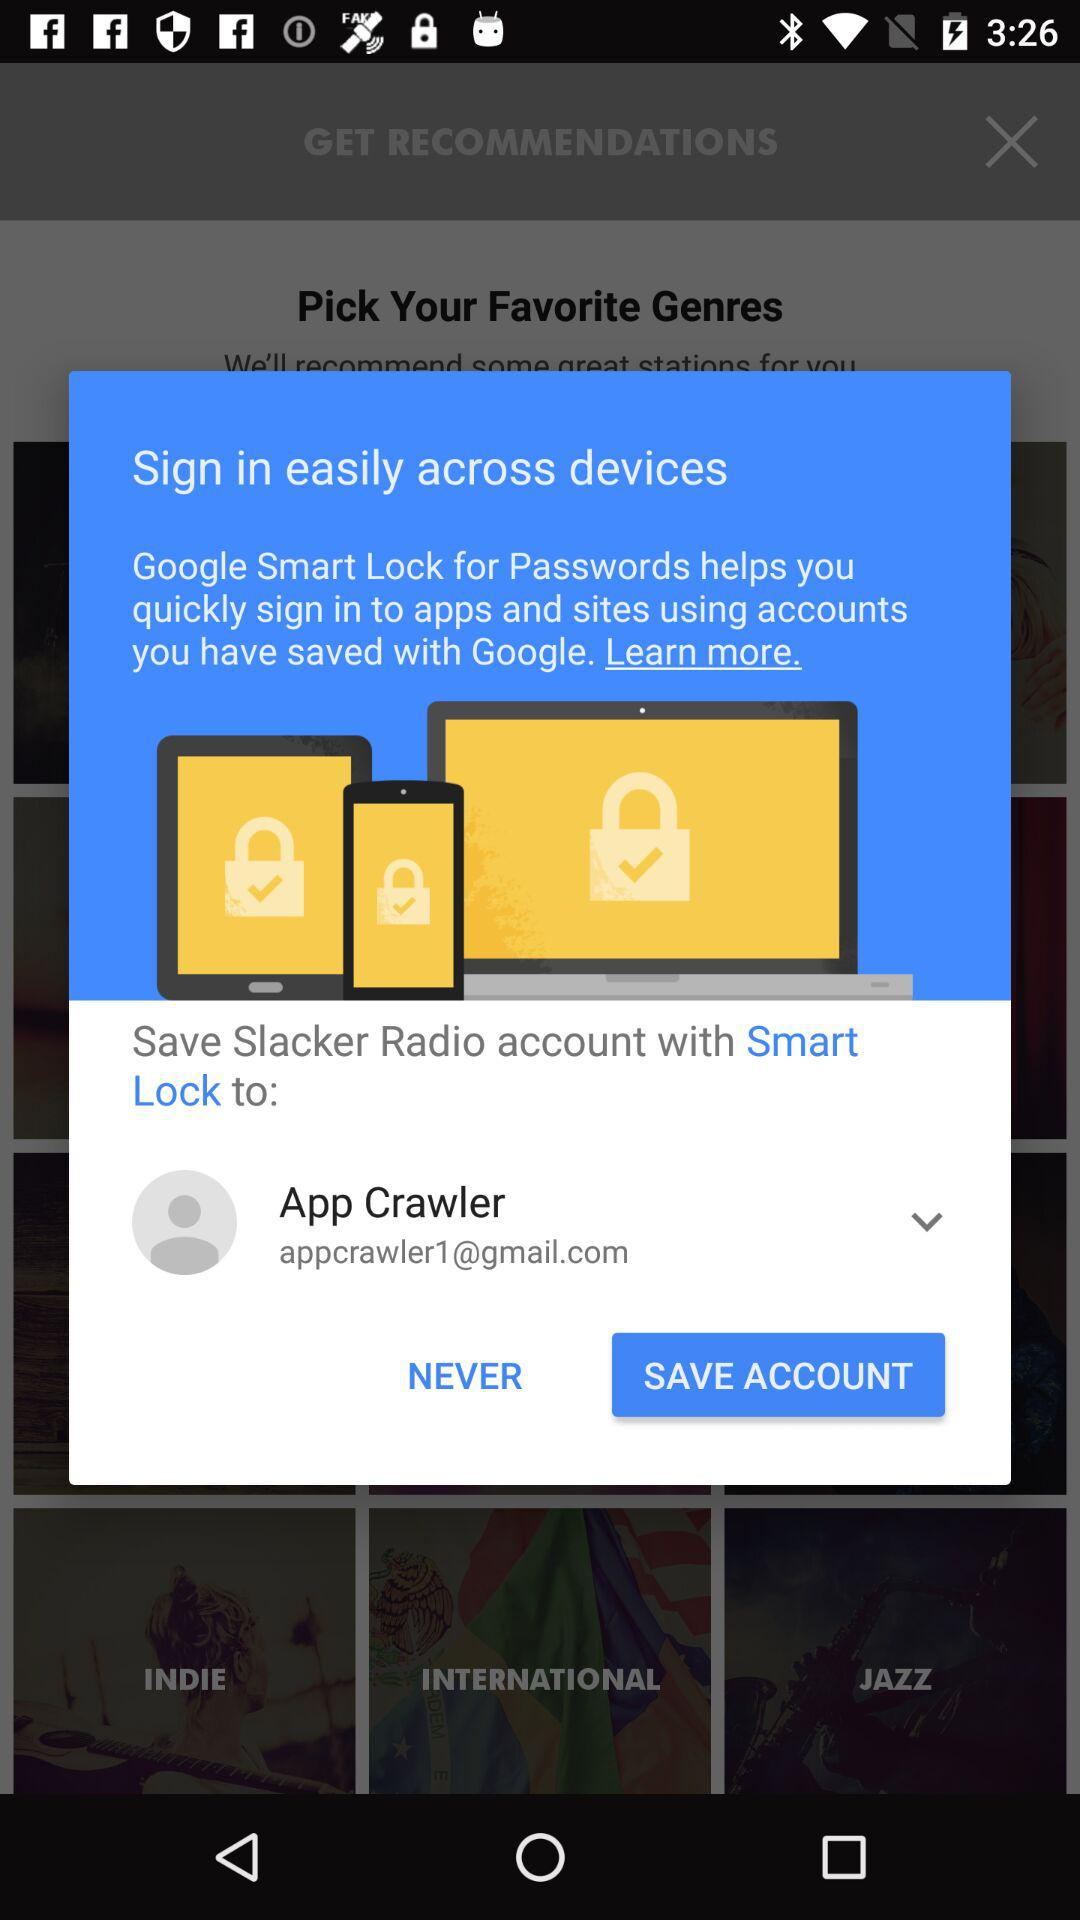What is the name of the application? The names of the applications are "Google Smart Lock" and "Slacker Radio". 